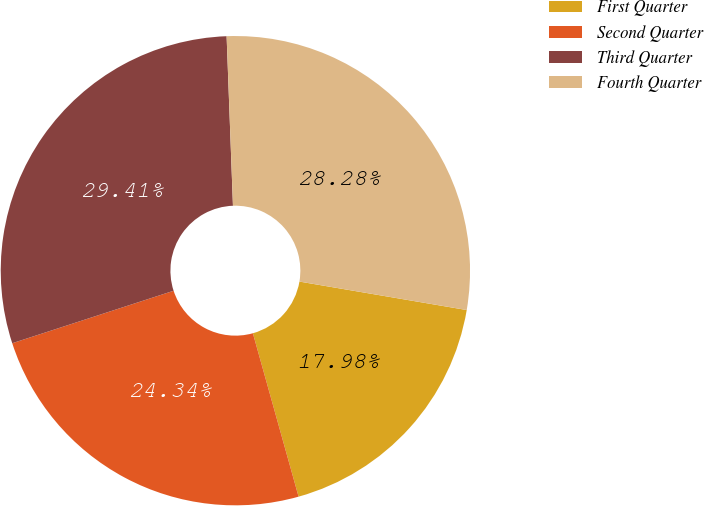Convert chart. <chart><loc_0><loc_0><loc_500><loc_500><pie_chart><fcel>First Quarter<fcel>Second Quarter<fcel>Third Quarter<fcel>Fourth Quarter<nl><fcel>17.98%<fcel>24.34%<fcel>29.41%<fcel>28.28%<nl></chart> 